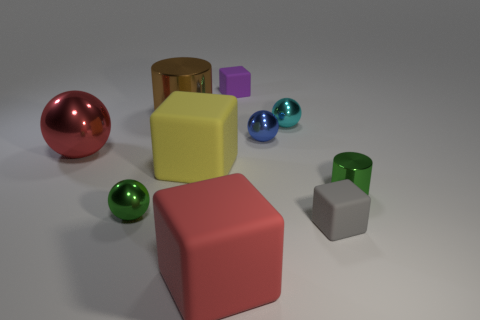Are there any cylinders of the same color as the big ball?
Offer a very short reply. No. Does the cyan object have the same shape as the blue metallic object?
Offer a terse response. Yes. What number of large things are either brown metallic objects or gray rubber things?
Provide a short and direct response. 1. The large object that is made of the same material as the big red sphere is what color?
Your response must be concise. Brown. What number of small red cylinders are made of the same material as the purple cube?
Your response must be concise. 0. There is a red object that is in front of the gray rubber object; is it the same size as the green metallic object on the right side of the large red cube?
Ensure brevity in your answer.  No. What material is the large red thing to the left of the big thing behind the red metal sphere?
Keep it short and to the point. Metal. Are there fewer tiny gray rubber things that are on the left side of the red metallic ball than big brown metal objects in front of the gray matte block?
Provide a succinct answer. No. There is a ball that is the same color as the small cylinder; what is it made of?
Give a very brief answer. Metal. Are there any other things that have the same shape as the big yellow thing?
Provide a short and direct response. Yes. 